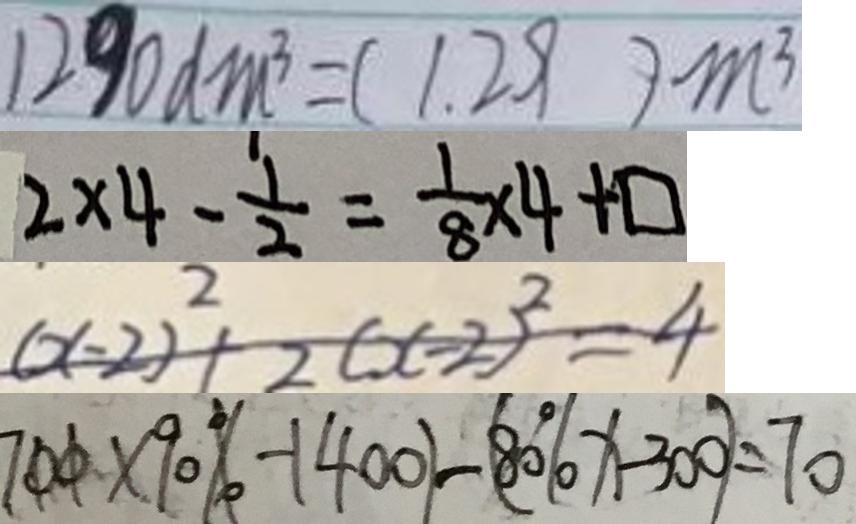<formula> <loc_0><loc_0><loc_500><loc_500>1 2 9 0 d m ^ { 3 } = ( 1 . 2 9 ) m ^ { 3 } 
 2 \times 4 - \frac { 1 } { 2 } = \frac { 1 } { 8 } \times 4 + \square 
 ( x - 2 ) ^ { 2 } + 2 ( x - 2 ) ^ { 2 } = 4 
 7 0 0 \times 9 0 \% - 1 4 0 0 ) - ( 8 0 \% x - 3 0 0 ) = 7 0</formula> 